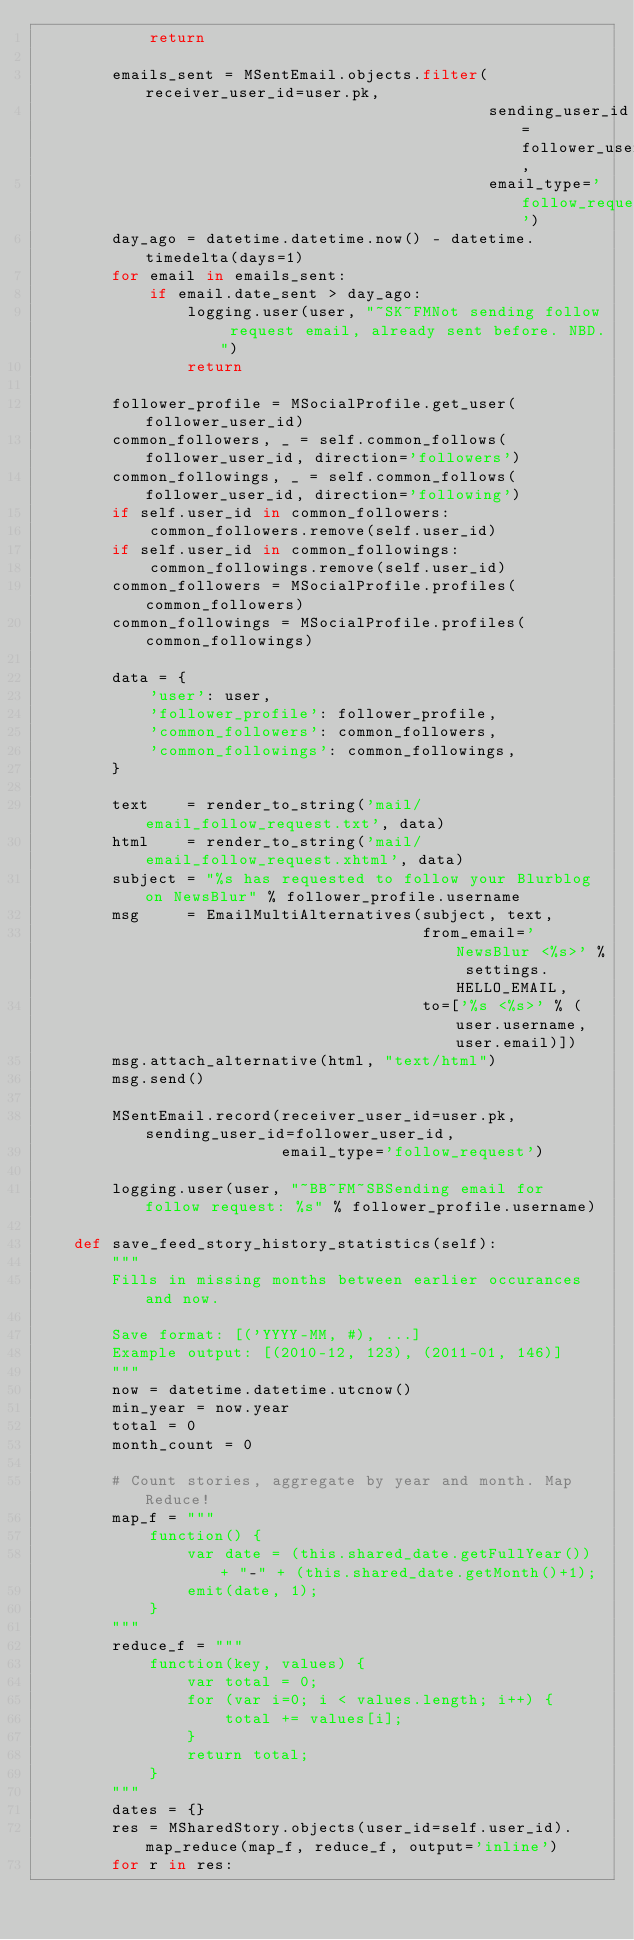Convert code to text. <code><loc_0><loc_0><loc_500><loc_500><_Python_>            return
        
        emails_sent = MSentEmail.objects.filter(receiver_user_id=user.pk,
                                                sending_user_id=follower_user_id,
                                                email_type='follow_request')
        day_ago = datetime.datetime.now() - datetime.timedelta(days=1)
        for email in emails_sent:
            if email.date_sent > day_ago:
                logging.user(user, "~SK~FMNot sending follow request email, already sent before. NBD.")
                return
        
        follower_profile = MSocialProfile.get_user(follower_user_id)
        common_followers, _ = self.common_follows(follower_user_id, direction='followers')
        common_followings, _ = self.common_follows(follower_user_id, direction='following')
        if self.user_id in common_followers:
            common_followers.remove(self.user_id)
        if self.user_id in common_followings:
            common_followings.remove(self.user_id)
        common_followers = MSocialProfile.profiles(common_followers)
        common_followings = MSocialProfile.profiles(common_followings)
        
        data = {
            'user': user,
            'follower_profile': follower_profile,
            'common_followers': common_followers,
            'common_followings': common_followings,
        }
        
        text    = render_to_string('mail/email_follow_request.txt', data)
        html    = render_to_string('mail/email_follow_request.xhtml', data)
        subject = "%s has requested to follow your Blurblog on NewsBlur" % follower_profile.username
        msg     = EmailMultiAlternatives(subject, text, 
                                         from_email='NewsBlur <%s>' % settings.HELLO_EMAIL,
                                         to=['%s <%s>' % (user.username, user.email)])
        msg.attach_alternative(html, "text/html")
        msg.send()
        
        MSentEmail.record(receiver_user_id=user.pk, sending_user_id=follower_user_id,
                          email_type='follow_request')
                
        logging.user(user, "~BB~FM~SBSending email for follow request: %s" % follower_profile.username)
            
    def save_feed_story_history_statistics(self):
        """
        Fills in missing months between earlier occurances and now.
        
        Save format: [('YYYY-MM, #), ...]
        Example output: [(2010-12, 123), (2011-01, 146)]
        """
        now = datetime.datetime.utcnow()
        min_year = now.year
        total = 0
        month_count = 0

        # Count stories, aggregate by year and month. Map Reduce!
        map_f = """
            function() {
                var date = (this.shared_date.getFullYear()) + "-" + (this.shared_date.getMonth()+1);
                emit(date, 1);
            }
        """
        reduce_f = """
            function(key, values) {
                var total = 0;
                for (var i=0; i < values.length; i++) {
                    total += values[i];
                }
                return total;
            }
        """
        dates = {}
        res = MSharedStory.objects(user_id=self.user_id).map_reduce(map_f, reduce_f, output='inline')
        for r in res:</code> 